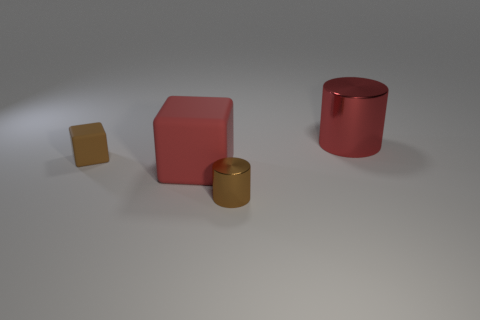Add 4 tiny brown cylinders. How many objects exist? 8 Add 2 large gray matte cylinders. How many large gray matte cylinders exist? 2 Subtract 0 purple cylinders. How many objects are left? 4 Subtract all tiny metallic things. Subtract all large red matte blocks. How many objects are left? 2 Add 4 cylinders. How many cylinders are left? 6 